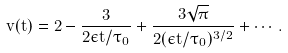<formula> <loc_0><loc_0><loc_500><loc_500>\tilde { v } ( t ) = 2 - \frac { 3 } { 2 \epsilon t / \tau _ { 0 } } + \frac { 3 \sqrt { \pi } } { 2 ( \epsilon t / \tau _ { 0 } ) ^ { 3 / 2 } } + \cdots .</formula> 